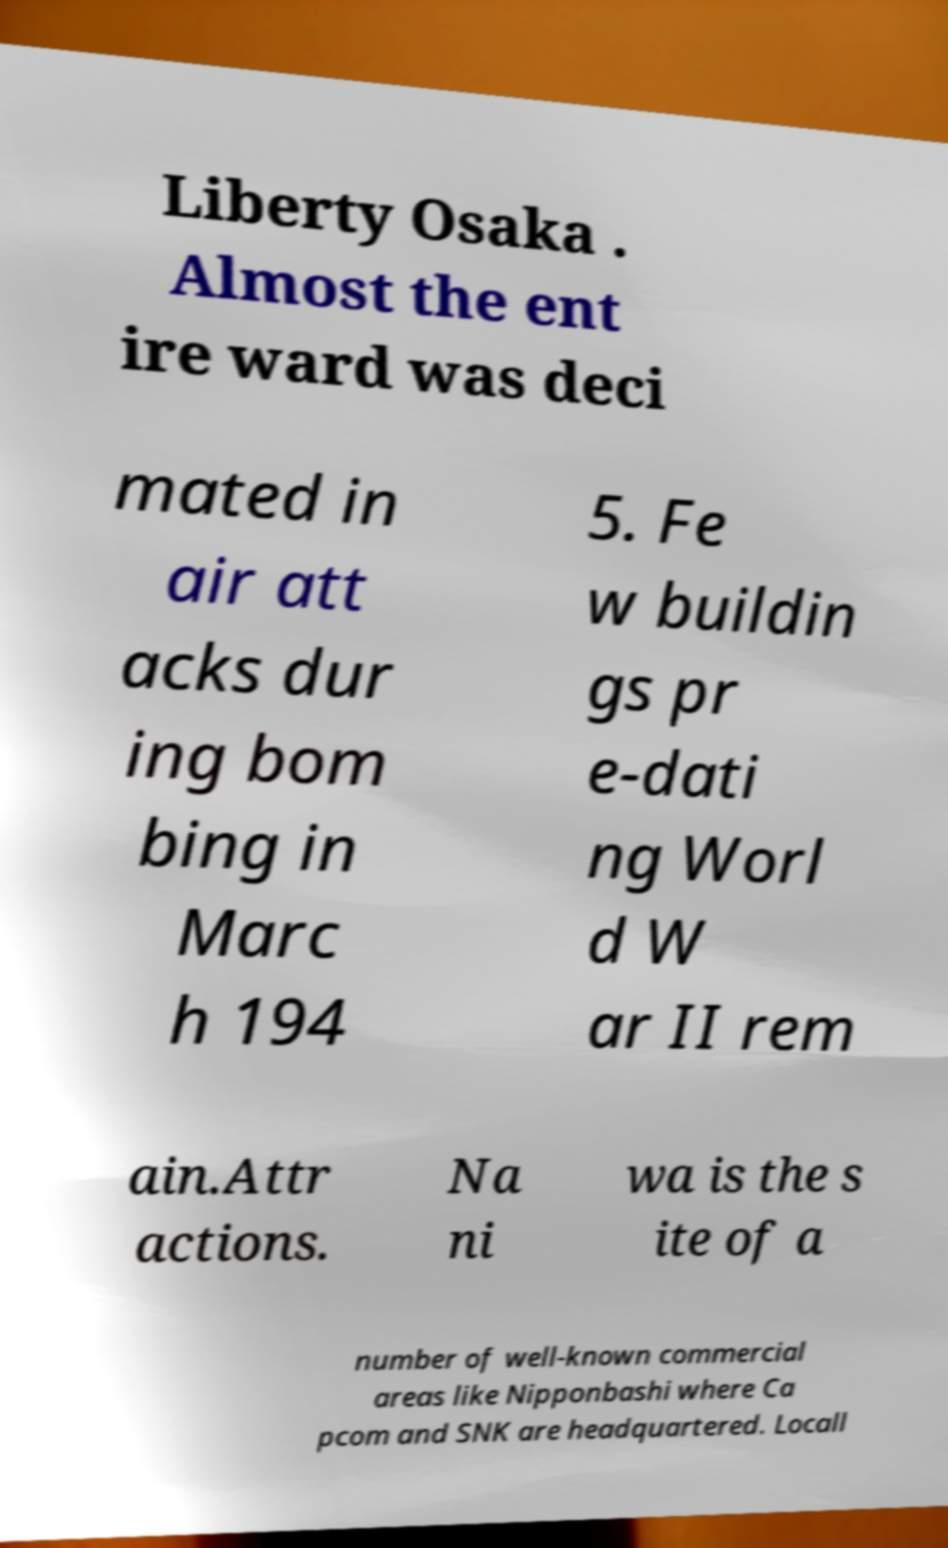What messages or text are displayed in this image? I need them in a readable, typed format. Liberty Osaka . Almost the ent ire ward was deci mated in air att acks dur ing bom bing in Marc h 194 5. Fe w buildin gs pr e-dati ng Worl d W ar II rem ain.Attr actions. Na ni wa is the s ite of a number of well-known commercial areas like Nipponbashi where Ca pcom and SNK are headquartered. Locall 